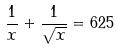Convert formula to latex. <formula><loc_0><loc_0><loc_500><loc_500>\frac { 1 } { x } + \frac { 1 } { \sqrt { x } } = 6 2 5</formula> 